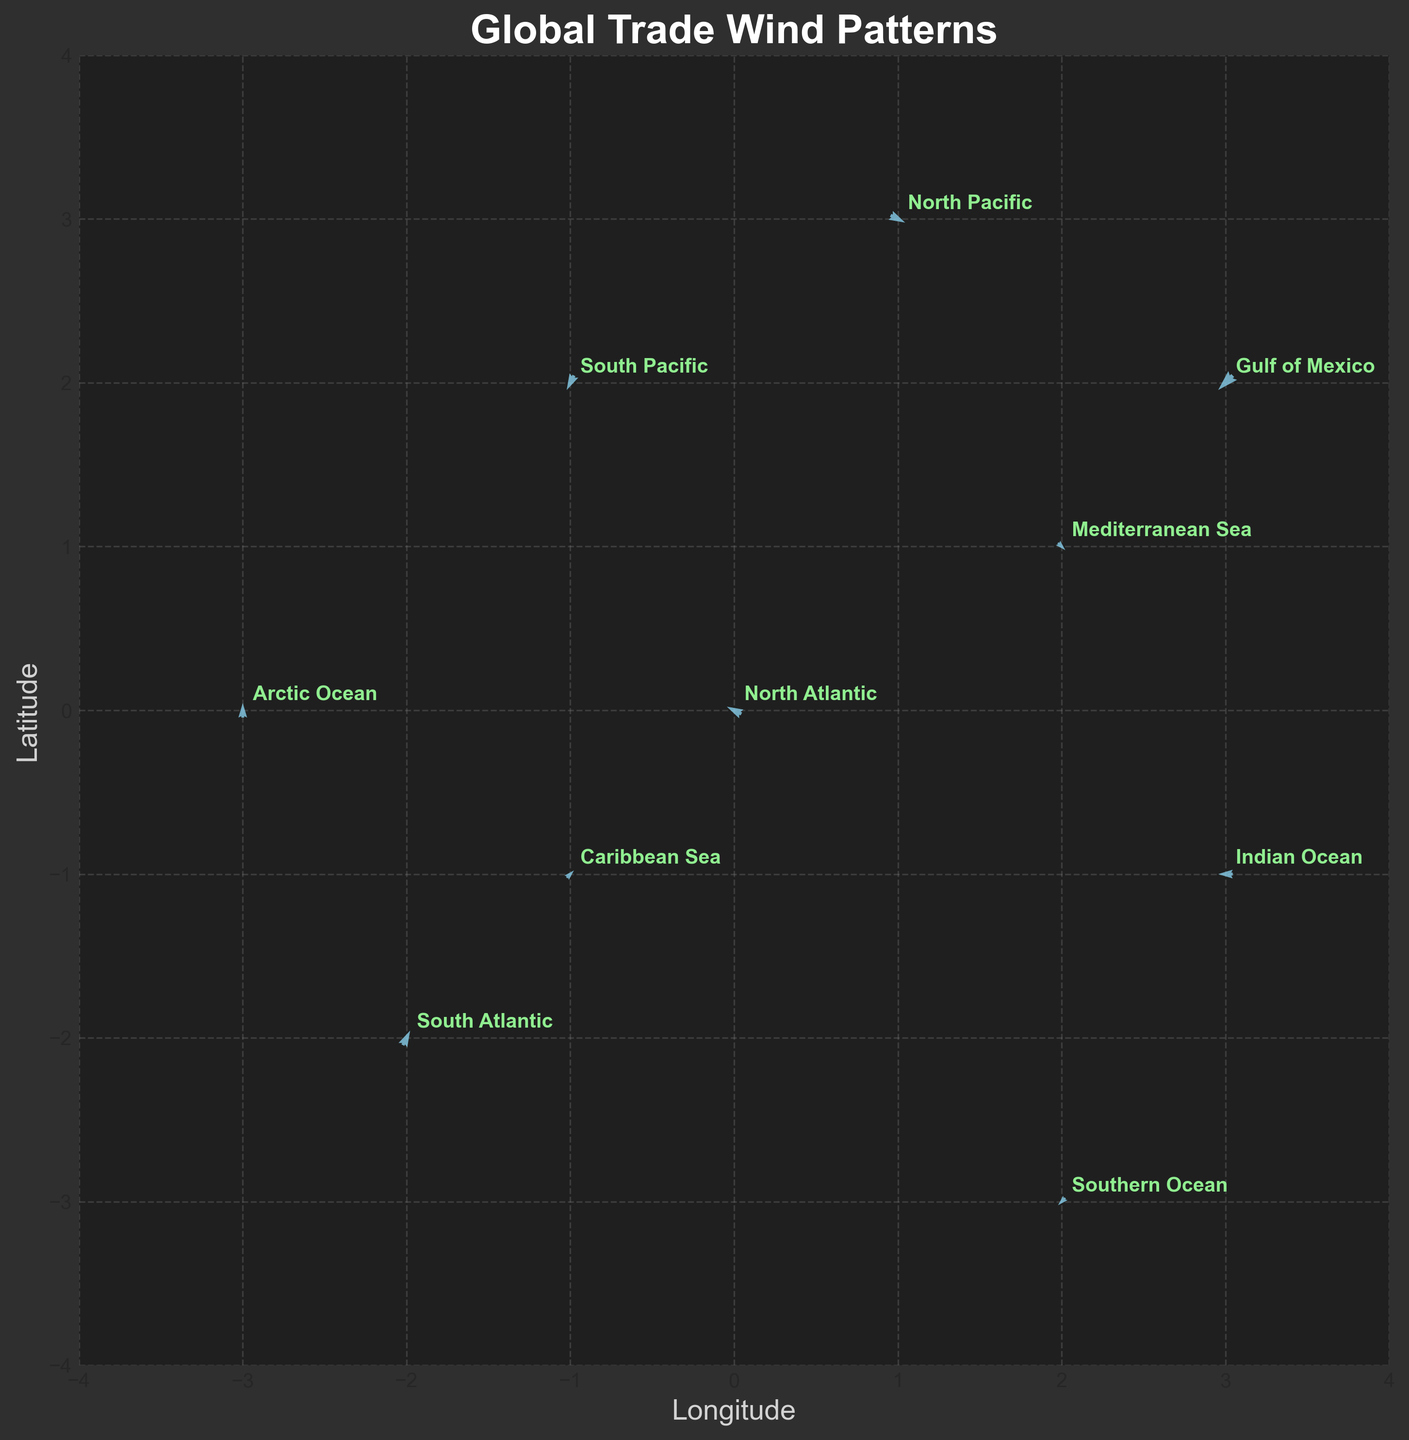What is the title of the figure? The title is displayed prominently at the top of the figure.
Answer: Global Trade Wind Patterns How many locations are shown on the plot? By counting all the annotations on the plot, you can determine the number of locations.
Answer: 10 What colors are used to represent the arrows and annotations? The arrows are color-coded in sky blue, while the annotations are in light green.
Answer: Sky blue and light green Which location has an arrow pointing in the northern direction? The direction of the arrow for each location needs to be examined. The arrow originating from the Arctic Ocean points north.
Answer: Arctic Ocean How does the wind direction for the Caribbean Sea compare to that of the Mediterranean Sea? Observing the direction of the arrows, the arrow from the Caribbean Sea points upwards and to the right (northeast), while the arrow from the Mediterranean Sea points towards the west and slightly downwards.
Answer: Caribbean Sea's wind direction is northeast, Mediterranean Sea's wind direction is west and slightly downward Which location has the longest wind vector? The length of the wind vectors can be compared visually. The arrow from the North Pacific appears to be the longest.
Answer: North Pacific What is the general direction of the wind arrow in the Southern Ocean compared to that in the Indian Ocean? By looking at the direction of each arrow, we see the arrow in the Southern Ocean points towards the southwest while the arrow in the Indian Ocean points towards the west.
Answer: Southern Ocean points southwest, Indian Ocean points west Are there any locations where the wind vector direction is purely vertical? Checking the start and end points of each arrow, the arrow from the Arctic Ocean points purely north (vertical).
Answer: Arctic Ocean What are the x and y coordinate ranges of the plot? The x and y axis limits are marked on the plot. The range for both axes is from -4 to 4.
Answer: -4 to 4 Which location shows a westward wind direction with no north or south movement? Identifying the direction of each arrow, the arrow in the Indian Ocean points directly west with no north or south movement.
Answer: Indian Ocean 